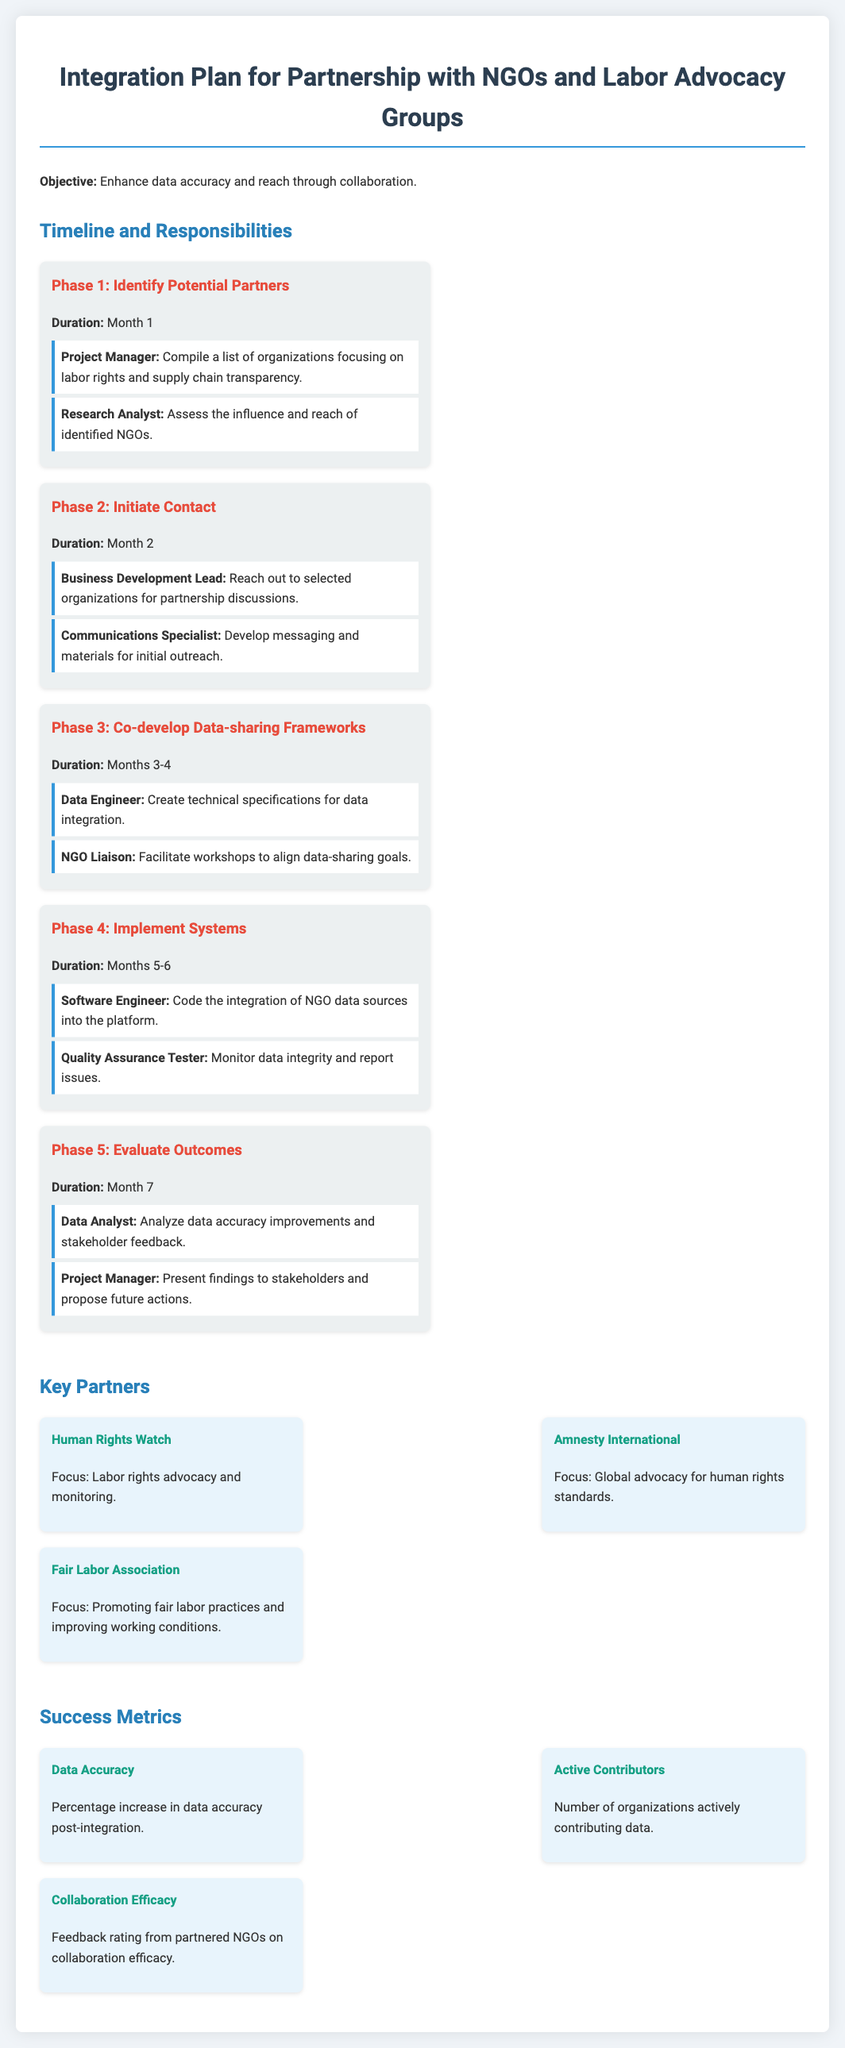What is the objective of the integration plan? The objective of the integration plan is stated in the document as enhancing data accuracy and reach through collaboration.
Answer: Enhance data accuracy and reach through collaboration What is the duration of Phase 2? The duration for Phase 2 is explicitly mentioned in the document.
Answer: Month 2 Who is responsible for assessing the influence and reach of identified NGOs? The responsibility for assessing the influence and reach is assigned to the Research Analyst as per the document.
Answer: Research Analyst What phase involves implementing systems? The document outlines that Phase 4 is focused on implementing systems.
Answer: Phase 4 Which organization focuses on promoting fair labor practices? The document lists the Fair Labor Association as the organization focusing on promoting fair labor practices.
Answer: Fair Labor Association What is one of the success metrics defined in the document? The document defines several success metrics, so the response will refer to the specific metric mentioned.
Answer: Data Accuracy How many phases are outlined in the integration plan? The total number of phases outlined can be found in the document.
Answer: Five Who will present findings to stakeholders in Phase 5? The document states that the Project Manager is responsible for presenting findings to stakeholders in Phase 5.
Answer: Project Manager What is the primary role of the NGO Liaison in Phase 3? The document describes the NGO Liaison's primary role in facilitating workshops to align data-sharing goals in Phase 3.
Answer: Facilitate workshops to align data-sharing goals 